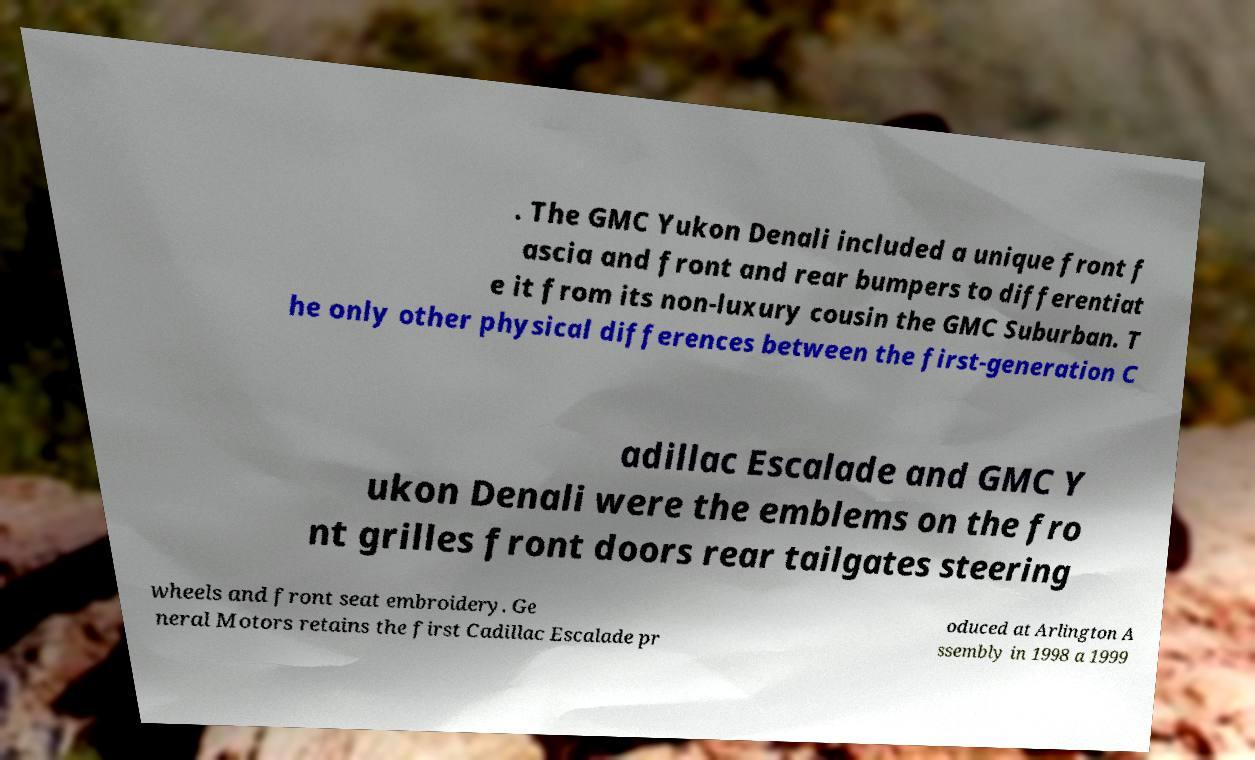Could you assist in decoding the text presented in this image and type it out clearly? . The GMC Yukon Denali included a unique front f ascia and front and rear bumpers to differentiat e it from its non-luxury cousin the GMC Suburban. T he only other physical differences between the first-generation C adillac Escalade and GMC Y ukon Denali were the emblems on the fro nt grilles front doors rear tailgates steering wheels and front seat embroidery. Ge neral Motors retains the first Cadillac Escalade pr oduced at Arlington A ssembly in 1998 a 1999 